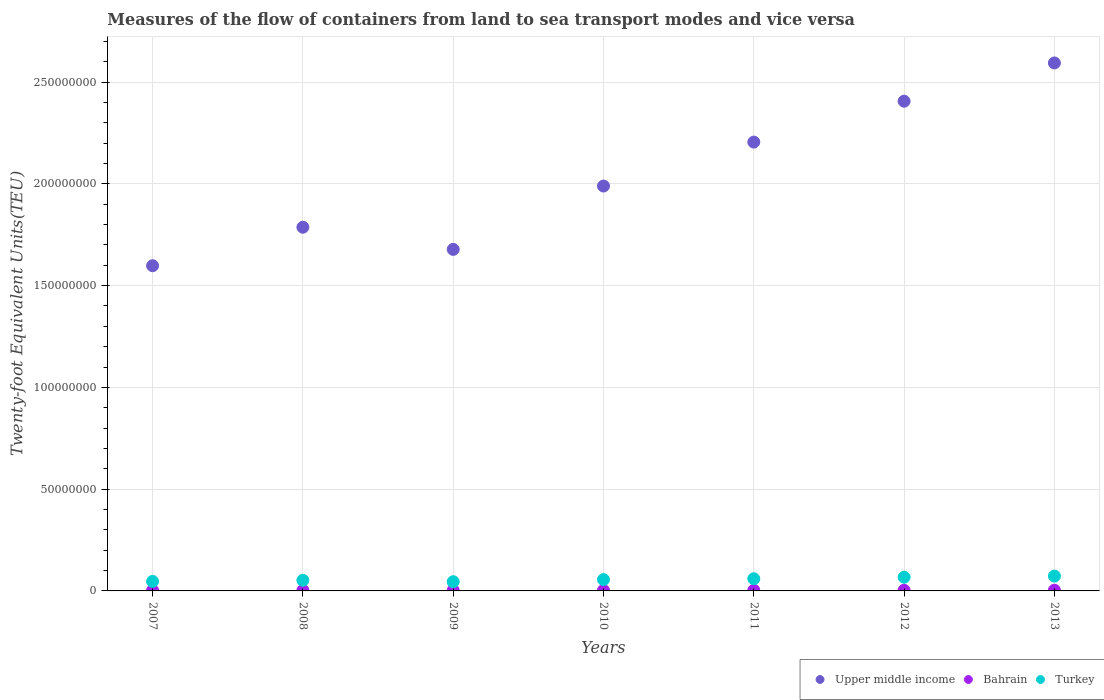What is the container port traffic in Bahrain in 2011?
Provide a short and direct response. 3.06e+05. Across all years, what is the maximum container port traffic in Turkey?
Offer a very short reply. 7.28e+06. Across all years, what is the minimum container port traffic in Upper middle income?
Give a very brief answer. 1.60e+08. In which year was the container port traffic in Upper middle income minimum?
Your response must be concise. 2007. What is the total container port traffic in Bahrain in the graph?
Provide a succinct answer. 2.07e+06. What is the difference between the container port traffic in Upper middle income in 2007 and that in 2013?
Offer a very short reply. -9.96e+07. What is the difference between the container port traffic in Bahrain in 2011 and the container port traffic in Upper middle income in 2007?
Offer a terse response. -1.59e+08. What is the average container port traffic in Upper middle income per year?
Keep it short and to the point. 2.04e+08. In the year 2010, what is the difference between the container port traffic in Turkey and container port traffic in Bahrain?
Your answer should be very brief. 5.28e+06. What is the ratio of the container port traffic in Turkey in 2009 to that in 2013?
Provide a short and direct response. 0.62. Is the difference between the container port traffic in Turkey in 2007 and 2013 greater than the difference between the container port traffic in Bahrain in 2007 and 2013?
Keep it short and to the point. No. What is the difference between the highest and the second highest container port traffic in Turkey?
Give a very brief answer. 5.48e+05. What is the difference between the highest and the lowest container port traffic in Upper middle income?
Your response must be concise. 9.96e+07. In how many years, is the container port traffic in Upper middle income greater than the average container port traffic in Upper middle income taken over all years?
Provide a succinct answer. 3. Is the sum of the container port traffic in Turkey in 2007 and 2012 greater than the maximum container port traffic in Bahrain across all years?
Your answer should be compact. Yes. Is it the case that in every year, the sum of the container port traffic in Turkey and container port traffic in Upper middle income  is greater than the container port traffic in Bahrain?
Your response must be concise. Yes. Is the container port traffic in Bahrain strictly less than the container port traffic in Upper middle income over the years?
Ensure brevity in your answer.  Yes. How many dotlines are there?
Provide a short and direct response. 3. How many years are there in the graph?
Keep it short and to the point. 7. What is the difference between two consecutive major ticks on the Y-axis?
Your response must be concise. 5.00e+07. Are the values on the major ticks of Y-axis written in scientific E-notation?
Ensure brevity in your answer.  No. Does the graph contain any zero values?
Give a very brief answer. No. Does the graph contain grids?
Provide a short and direct response. Yes. Where does the legend appear in the graph?
Your response must be concise. Bottom right. How many legend labels are there?
Provide a short and direct response. 3. What is the title of the graph?
Provide a succinct answer. Measures of the flow of containers from land to sea transport modes and vice versa. Does "Chile" appear as one of the legend labels in the graph?
Keep it short and to the point. No. What is the label or title of the X-axis?
Offer a very short reply. Years. What is the label or title of the Y-axis?
Make the answer very short. Twenty-foot Equivalent Units(TEU). What is the Twenty-foot Equivalent Units(TEU) of Upper middle income in 2007?
Your answer should be compact. 1.60e+08. What is the Twenty-foot Equivalent Units(TEU) of Bahrain in 2007?
Make the answer very short. 2.39e+05. What is the Twenty-foot Equivalent Units(TEU) in Turkey in 2007?
Keep it short and to the point. 4.68e+06. What is the Twenty-foot Equivalent Units(TEU) in Upper middle income in 2008?
Your answer should be very brief. 1.79e+08. What is the Twenty-foot Equivalent Units(TEU) of Bahrain in 2008?
Your answer should be very brief. 2.69e+05. What is the Twenty-foot Equivalent Units(TEU) of Turkey in 2008?
Give a very brief answer. 5.22e+06. What is the Twenty-foot Equivalent Units(TEU) of Upper middle income in 2009?
Your answer should be very brief. 1.68e+08. What is the Twenty-foot Equivalent Units(TEU) of Bahrain in 2009?
Keep it short and to the point. 2.80e+05. What is the Twenty-foot Equivalent Units(TEU) of Turkey in 2009?
Give a very brief answer. 4.52e+06. What is the Twenty-foot Equivalent Units(TEU) of Upper middle income in 2010?
Provide a succinct answer. 1.99e+08. What is the Twenty-foot Equivalent Units(TEU) in Bahrain in 2010?
Make the answer very short. 2.90e+05. What is the Twenty-foot Equivalent Units(TEU) in Turkey in 2010?
Your response must be concise. 5.57e+06. What is the Twenty-foot Equivalent Units(TEU) in Upper middle income in 2011?
Provide a succinct answer. 2.21e+08. What is the Twenty-foot Equivalent Units(TEU) of Bahrain in 2011?
Provide a succinct answer. 3.06e+05. What is the Twenty-foot Equivalent Units(TEU) in Turkey in 2011?
Your answer should be compact. 5.99e+06. What is the Twenty-foot Equivalent Units(TEU) of Upper middle income in 2012?
Give a very brief answer. 2.41e+08. What is the Twenty-foot Equivalent Units(TEU) in Bahrain in 2012?
Provide a succinct answer. 3.29e+05. What is the Twenty-foot Equivalent Units(TEU) of Turkey in 2012?
Provide a succinct answer. 6.74e+06. What is the Twenty-foot Equivalent Units(TEU) in Upper middle income in 2013?
Your answer should be very brief. 2.59e+08. What is the Twenty-foot Equivalent Units(TEU) of Bahrain in 2013?
Provide a succinct answer. 3.55e+05. What is the Twenty-foot Equivalent Units(TEU) in Turkey in 2013?
Make the answer very short. 7.28e+06. Across all years, what is the maximum Twenty-foot Equivalent Units(TEU) of Upper middle income?
Offer a very short reply. 2.59e+08. Across all years, what is the maximum Twenty-foot Equivalent Units(TEU) in Bahrain?
Your answer should be compact. 3.55e+05. Across all years, what is the maximum Twenty-foot Equivalent Units(TEU) in Turkey?
Make the answer very short. 7.28e+06. Across all years, what is the minimum Twenty-foot Equivalent Units(TEU) of Upper middle income?
Give a very brief answer. 1.60e+08. Across all years, what is the minimum Twenty-foot Equivalent Units(TEU) of Bahrain?
Ensure brevity in your answer.  2.39e+05. Across all years, what is the minimum Twenty-foot Equivalent Units(TEU) of Turkey?
Make the answer very short. 4.52e+06. What is the total Twenty-foot Equivalent Units(TEU) of Upper middle income in the graph?
Keep it short and to the point. 1.43e+09. What is the total Twenty-foot Equivalent Units(TEU) of Bahrain in the graph?
Keep it short and to the point. 2.07e+06. What is the total Twenty-foot Equivalent Units(TEU) in Turkey in the graph?
Offer a very short reply. 4.00e+07. What is the difference between the Twenty-foot Equivalent Units(TEU) in Upper middle income in 2007 and that in 2008?
Make the answer very short. -1.89e+07. What is the difference between the Twenty-foot Equivalent Units(TEU) in Bahrain in 2007 and that in 2008?
Make the answer very short. -3.07e+04. What is the difference between the Twenty-foot Equivalent Units(TEU) in Turkey in 2007 and that in 2008?
Offer a terse response. -5.39e+05. What is the difference between the Twenty-foot Equivalent Units(TEU) in Upper middle income in 2007 and that in 2009?
Offer a very short reply. -8.03e+06. What is the difference between the Twenty-foot Equivalent Units(TEU) of Bahrain in 2007 and that in 2009?
Your answer should be compact. -4.12e+04. What is the difference between the Twenty-foot Equivalent Units(TEU) of Turkey in 2007 and that in 2009?
Ensure brevity in your answer.  1.57e+05. What is the difference between the Twenty-foot Equivalent Units(TEU) in Upper middle income in 2007 and that in 2010?
Offer a very short reply. -3.92e+07. What is the difference between the Twenty-foot Equivalent Units(TEU) of Bahrain in 2007 and that in 2010?
Provide a short and direct response. -5.13e+04. What is the difference between the Twenty-foot Equivalent Units(TEU) in Turkey in 2007 and that in 2010?
Ensure brevity in your answer.  -8.95e+05. What is the difference between the Twenty-foot Equivalent Units(TEU) in Upper middle income in 2007 and that in 2011?
Your answer should be compact. -6.07e+07. What is the difference between the Twenty-foot Equivalent Units(TEU) in Bahrain in 2007 and that in 2011?
Give a very brief answer. -6.79e+04. What is the difference between the Twenty-foot Equivalent Units(TEU) in Turkey in 2007 and that in 2011?
Provide a succinct answer. -1.31e+06. What is the difference between the Twenty-foot Equivalent Units(TEU) in Upper middle income in 2007 and that in 2012?
Provide a short and direct response. -8.08e+07. What is the difference between the Twenty-foot Equivalent Units(TEU) in Bahrain in 2007 and that in 2012?
Ensure brevity in your answer.  -9.08e+04. What is the difference between the Twenty-foot Equivalent Units(TEU) of Turkey in 2007 and that in 2012?
Offer a very short reply. -2.06e+06. What is the difference between the Twenty-foot Equivalent Units(TEU) of Upper middle income in 2007 and that in 2013?
Ensure brevity in your answer.  -9.96e+07. What is the difference between the Twenty-foot Equivalent Units(TEU) of Bahrain in 2007 and that in 2013?
Ensure brevity in your answer.  -1.17e+05. What is the difference between the Twenty-foot Equivalent Units(TEU) in Turkey in 2007 and that in 2013?
Offer a very short reply. -2.61e+06. What is the difference between the Twenty-foot Equivalent Units(TEU) of Upper middle income in 2008 and that in 2009?
Your answer should be very brief. 1.09e+07. What is the difference between the Twenty-foot Equivalent Units(TEU) in Bahrain in 2008 and that in 2009?
Provide a succinct answer. -1.05e+04. What is the difference between the Twenty-foot Equivalent Units(TEU) in Turkey in 2008 and that in 2009?
Your response must be concise. 6.97e+05. What is the difference between the Twenty-foot Equivalent Units(TEU) in Upper middle income in 2008 and that in 2010?
Keep it short and to the point. -2.02e+07. What is the difference between the Twenty-foot Equivalent Units(TEU) of Bahrain in 2008 and that in 2010?
Offer a very short reply. -2.06e+04. What is the difference between the Twenty-foot Equivalent Units(TEU) of Turkey in 2008 and that in 2010?
Your response must be concise. -3.56e+05. What is the difference between the Twenty-foot Equivalent Units(TEU) in Upper middle income in 2008 and that in 2011?
Keep it short and to the point. -4.18e+07. What is the difference between the Twenty-foot Equivalent Units(TEU) of Bahrain in 2008 and that in 2011?
Your answer should be very brief. -3.72e+04. What is the difference between the Twenty-foot Equivalent Units(TEU) of Turkey in 2008 and that in 2011?
Provide a short and direct response. -7.72e+05. What is the difference between the Twenty-foot Equivalent Units(TEU) of Upper middle income in 2008 and that in 2012?
Keep it short and to the point. -6.19e+07. What is the difference between the Twenty-foot Equivalent Units(TEU) in Bahrain in 2008 and that in 2012?
Offer a terse response. -6.01e+04. What is the difference between the Twenty-foot Equivalent Units(TEU) of Turkey in 2008 and that in 2012?
Give a very brief answer. -1.52e+06. What is the difference between the Twenty-foot Equivalent Units(TEU) of Upper middle income in 2008 and that in 2013?
Give a very brief answer. -8.07e+07. What is the difference between the Twenty-foot Equivalent Units(TEU) of Bahrain in 2008 and that in 2013?
Provide a short and direct response. -8.62e+04. What is the difference between the Twenty-foot Equivalent Units(TEU) of Turkey in 2008 and that in 2013?
Your answer should be compact. -2.07e+06. What is the difference between the Twenty-foot Equivalent Units(TEU) in Upper middle income in 2009 and that in 2010?
Your answer should be very brief. -3.11e+07. What is the difference between the Twenty-foot Equivalent Units(TEU) of Bahrain in 2009 and that in 2010?
Offer a very short reply. -1.02e+04. What is the difference between the Twenty-foot Equivalent Units(TEU) in Turkey in 2009 and that in 2010?
Make the answer very short. -1.05e+06. What is the difference between the Twenty-foot Equivalent Units(TEU) of Upper middle income in 2009 and that in 2011?
Your answer should be very brief. -5.27e+07. What is the difference between the Twenty-foot Equivalent Units(TEU) of Bahrain in 2009 and that in 2011?
Make the answer very short. -2.67e+04. What is the difference between the Twenty-foot Equivalent Units(TEU) of Turkey in 2009 and that in 2011?
Keep it short and to the point. -1.47e+06. What is the difference between the Twenty-foot Equivalent Units(TEU) in Upper middle income in 2009 and that in 2012?
Provide a short and direct response. -7.28e+07. What is the difference between the Twenty-foot Equivalent Units(TEU) of Bahrain in 2009 and that in 2012?
Provide a succinct answer. -4.97e+04. What is the difference between the Twenty-foot Equivalent Units(TEU) of Turkey in 2009 and that in 2012?
Offer a very short reply. -2.21e+06. What is the difference between the Twenty-foot Equivalent Units(TEU) in Upper middle income in 2009 and that in 2013?
Offer a very short reply. -9.16e+07. What is the difference between the Twenty-foot Equivalent Units(TEU) in Bahrain in 2009 and that in 2013?
Provide a short and direct response. -7.57e+04. What is the difference between the Twenty-foot Equivalent Units(TEU) in Turkey in 2009 and that in 2013?
Give a very brief answer. -2.76e+06. What is the difference between the Twenty-foot Equivalent Units(TEU) of Upper middle income in 2010 and that in 2011?
Your response must be concise. -2.16e+07. What is the difference between the Twenty-foot Equivalent Units(TEU) in Bahrain in 2010 and that in 2011?
Provide a succinct answer. -1.65e+04. What is the difference between the Twenty-foot Equivalent Units(TEU) in Turkey in 2010 and that in 2011?
Keep it short and to the point. -4.16e+05. What is the difference between the Twenty-foot Equivalent Units(TEU) in Upper middle income in 2010 and that in 2012?
Ensure brevity in your answer.  -4.17e+07. What is the difference between the Twenty-foot Equivalent Units(TEU) in Bahrain in 2010 and that in 2012?
Provide a short and direct response. -3.95e+04. What is the difference between the Twenty-foot Equivalent Units(TEU) in Turkey in 2010 and that in 2012?
Offer a very short reply. -1.16e+06. What is the difference between the Twenty-foot Equivalent Units(TEU) of Upper middle income in 2010 and that in 2013?
Give a very brief answer. -6.05e+07. What is the difference between the Twenty-foot Equivalent Units(TEU) in Bahrain in 2010 and that in 2013?
Provide a short and direct response. -6.55e+04. What is the difference between the Twenty-foot Equivalent Units(TEU) of Turkey in 2010 and that in 2013?
Offer a terse response. -1.71e+06. What is the difference between the Twenty-foot Equivalent Units(TEU) in Upper middle income in 2011 and that in 2012?
Offer a terse response. -2.01e+07. What is the difference between the Twenty-foot Equivalent Units(TEU) in Bahrain in 2011 and that in 2012?
Ensure brevity in your answer.  -2.30e+04. What is the difference between the Twenty-foot Equivalent Units(TEU) of Turkey in 2011 and that in 2012?
Provide a succinct answer. -7.46e+05. What is the difference between the Twenty-foot Equivalent Units(TEU) in Upper middle income in 2011 and that in 2013?
Your answer should be compact. -3.89e+07. What is the difference between the Twenty-foot Equivalent Units(TEU) in Bahrain in 2011 and that in 2013?
Your answer should be compact. -4.90e+04. What is the difference between the Twenty-foot Equivalent Units(TEU) of Turkey in 2011 and that in 2013?
Provide a short and direct response. -1.29e+06. What is the difference between the Twenty-foot Equivalent Units(TEU) of Upper middle income in 2012 and that in 2013?
Your answer should be compact. -1.88e+07. What is the difference between the Twenty-foot Equivalent Units(TEU) in Bahrain in 2012 and that in 2013?
Offer a terse response. -2.60e+04. What is the difference between the Twenty-foot Equivalent Units(TEU) of Turkey in 2012 and that in 2013?
Provide a succinct answer. -5.48e+05. What is the difference between the Twenty-foot Equivalent Units(TEU) in Upper middle income in 2007 and the Twenty-foot Equivalent Units(TEU) in Bahrain in 2008?
Give a very brief answer. 1.60e+08. What is the difference between the Twenty-foot Equivalent Units(TEU) of Upper middle income in 2007 and the Twenty-foot Equivalent Units(TEU) of Turkey in 2008?
Ensure brevity in your answer.  1.55e+08. What is the difference between the Twenty-foot Equivalent Units(TEU) of Bahrain in 2007 and the Twenty-foot Equivalent Units(TEU) of Turkey in 2008?
Provide a short and direct response. -4.98e+06. What is the difference between the Twenty-foot Equivalent Units(TEU) of Upper middle income in 2007 and the Twenty-foot Equivalent Units(TEU) of Bahrain in 2009?
Your answer should be very brief. 1.60e+08. What is the difference between the Twenty-foot Equivalent Units(TEU) of Upper middle income in 2007 and the Twenty-foot Equivalent Units(TEU) of Turkey in 2009?
Ensure brevity in your answer.  1.55e+08. What is the difference between the Twenty-foot Equivalent Units(TEU) in Bahrain in 2007 and the Twenty-foot Equivalent Units(TEU) in Turkey in 2009?
Keep it short and to the point. -4.28e+06. What is the difference between the Twenty-foot Equivalent Units(TEU) in Upper middle income in 2007 and the Twenty-foot Equivalent Units(TEU) in Bahrain in 2010?
Provide a succinct answer. 1.59e+08. What is the difference between the Twenty-foot Equivalent Units(TEU) of Upper middle income in 2007 and the Twenty-foot Equivalent Units(TEU) of Turkey in 2010?
Provide a succinct answer. 1.54e+08. What is the difference between the Twenty-foot Equivalent Units(TEU) in Bahrain in 2007 and the Twenty-foot Equivalent Units(TEU) in Turkey in 2010?
Provide a succinct answer. -5.34e+06. What is the difference between the Twenty-foot Equivalent Units(TEU) of Upper middle income in 2007 and the Twenty-foot Equivalent Units(TEU) of Bahrain in 2011?
Your answer should be very brief. 1.59e+08. What is the difference between the Twenty-foot Equivalent Units(TEU) in Upper middle income in 2007 and the Twenty-foot Equivalent Units(TEU) in Turkey in 2011?
Provide a succinct answer. 1.54e+08. What is the difference between the Twenty-foot Equivalent Units(TEU) in Bahrain in 2007 and the Twenty-foot Equivalent Units(TEU) in Turkey in 2011?
Your response must be concise. -5.75e+06. What is the difference between the Twenty-foot Equivalent Units(TEU) in Upper middle income in 2007 and the Twenty-foot Equivalent Units(TEU) in Bahrain in 2012?
Provide a short and direct response. 1.59e+08. What is the difference between the Twenty-foot Equivalent Units(TEU) in Upper middle income in 2007 and the Twenty-foot Equivalent Units(TEU) in Turkey in 2012?
Offer a very short reply. 1.53e+08. What is the difference between the Twenty-foot Equivalent Units(TEU) in Bahrain in 2007 and the Twenty-foot Equivalent Units(TEU) in Turkey in 2012?
Give a very brief answer. -6.50e+06. What is the difference between the Twenty-foot Equivalent Units(TEU) in Upper middle income in 2007 and the Twenty-foot Equivalent Units(TEU) in Bahrain in 2013?
Offer a terse response. 1.59e+08. What is the difference between the Twenty-foot Equivalent Units(TEU) of Upper middle income in 2007 and the Twenty-foot Equivalent Units(TEU) of Turkey in 2013?
Keep it short and to the point. 1.53e+08. What is the difference between the Twenty-foot Equivalent Units(TEU) of Bahrain in 2007 and the Twenty-foot Equivalent Units(TEU) of Turkey in 2013?
Ensure brevity in your answer.  -7.05e+06. What is the difference between the Twenty-foot Equivalent Units(TEU) of Upper middle income in 2008 and the Twenty-foot Equivalent Units(TEU) of Bahrain in 2009?
Offer a very short reply. 1.78e+08. What is the difference between the Twenty-foot Equivalent Units(TEU) in Upper middle income in 2008 and the Twenty-foot Equivalent Units(TEU) in Turkey in 2009?
Keep it short and to the point. 1.74e+08. What is the difference between the Twenty-foot Equivalent Units(TEU) in Bahrain in 2008 and the Twenty-foot Equivalent Units(TEU) in Turkey in 2009?
Provide a short and direct response. -4.25e+06. What is the difference between the Twenty-foot Equivalent Units(TEU) of Upper middle income in 2008 and the Twenty-foot Equivalent Units(TEU) of Bahrain in 2010?
Give a very brief answer. 1.78e+08. What is the difference between the Twenty-foot Equivalent Units(TEU) in Upper middle income in 2008 and the Twenty-foot Equivalent Units(TEU) in Turkey in 2010?
Make the answer very short. 1.73e+08. What is the difference between the Twenty-foot Equivalent Units(TEU) of Bahrain in 2008 and the Twenty-foot Equivalent Units(TEU) of Turkey in 2010?
Your answer should be very brief. -5.30e+06. What is the difference between the Twenty-foot Equivalent Units(TEU) in Upper middle income in 2008 and the Twenty-foot Equivalent Units(TEU) in Bahrain in 2011?
Offer a terse response. 1.78e+08. What is the difference between the Twenty-foot Equivalent Units(TEU) of Upper middle income in 2008 and the Twenty-foot Equivalent Units(TEU) of Turkey in 2011?
Make the answer very short. 1.73e+08. What is the difference between the Twenty-foot Equivalent Units(TEU) of Bahrain in 2008 and the Twenty-foot Equivalent Units(TEU) of Turkey in 2011?
Your answer should be very brief. -5.72e+06. What is the difference between the Twenty-foot Equivalent Units(TEU) in Upper middle income in 2008 and the Twenty-foot Equivalent Units(TEU) in Bahrain in 2012?
Provide a succinct answer. 1.78e+08. What is the difference between the Twenty-foot Equivalent Units(TEU) of Upper middle income in 2008 and the Twenty-foot Equivalent Units(TEU) of Turkey in 2012?
Your answer should be compact. 1.72e+08. What is the difference between the Twenty-foot Equivalent Units(TEU) of Bahrain in 2008 and the Twenty-foot Equivalent Units(TEU) of Turkey in 2012?
Your answer should be compact. -6.47e+06. What is the difference between the Twenty-foot Equivalent Units(TEU) of Upper middle income in 2008 and the Twenty-foot Equivalent Units(TEU) of Bahrain in 2013?
Give a very brief answer. 1.78e+08. What is the difference between the Twenty-foot Equivalent Units(TEU) of Upper middle income in 2008 and the Twenty-foot Equivalent Units(TEU) of Turkey in 2013?
Offer a terse response. 1.71e+08. What is the difference between the Twenty-foot Equivalent Units(TEU) of Bahrain in 2008 and the Twenty-foot Equivalent Units(TEU) of Turkey in 2013?
Your answer should be compact. -7.01e+06. What is the difference between the Twenty-foot Equivalent Units(TEU) in Upper middle income in 2009 and the Twenty-foot Equivalent Units(TEU) in Bahrain in 2010?
Your response must be concise. 1.68e+08. What is the difference between the Twenty-foot Equivalent Units(TEU) in Upper middle income in 2009 and the Twenty-foot Equivalent Units(TEU) in Turkey in 2010?
Give a very brief answer. 1.62e+08. What is the difference between the Twenty-foot Equivalent Units(TEU) of Bahrain in 2009 and the Twenty-foot Equivalent Units(TEU) of Turkey in 2010?
Provide a succinct answer. -5.29e+06. What is the difference between the Twenty-foot Equivalent Units(TEU) in Upper middle income in 2009 and the Twenty-foot Equivalent Units(TEU) in Bahrain in 2011?
Your response must be concise. 1.68e+08. What is the difference between the Twenty-foot Equivalent Units(TEU) in Upper middle income in 2009 and the Twenty-foot Equivalent Units(TEU) in Turkey in 2011?
Your response must be concise. 1.62e+08. What is the difference between the Twenty-foot Equivalent Units(TEU) of Bahrain in 2009 and the Twenty-foot Equivalent Units(TEU) of Turkey in 2011?
Offer a terse response. -5.71e+06. What is the difference between the Twenty-foot Equivalent Units(TEU) of Upper middle income in 2009 and the Twenty-foot Equivalent Units(TEU) of Bahrain in 2012?
Your response must be concise. 1.67e+08. What is the difference between the Twenty-foot Equivalent Units(TEU) of Upper middle income in 2009 and the Twenty-foot Equivalent Units(TEU) of Turkey in 2012?
Your response must be concise. 1.61e+08. What is the difference between the Twenty-foot Equivalent Units(TEU) in Bahrain in 2009 and the Twenty-foot Equivalent Units(TEU) in Turkey in 2012?
Ensure brevity in your answer.  -6.46e+06. What is the difference between the Twenty-foot Equivalent Units(TEU) in Upper middle income in 2009 and the Twenty-foot Equivalent Units(TEU) in Bahrain in 2013?
Provide a short and direct response. 1.67e+08. What is the difference between the Twenty-foot Equivalent Units(TEU) in Upper middle income in 2009 and the Twenty-foot Equivalent Units(TEU) in Turkey in 2013?
Keep it short and to the point. 1.61e+08. What is the difference between the Twenty-foot Equivalent Units(TEU) of Bahrain in 2009 and the Twenty-foot Equivalent Units(TEU) of Turkey in 2013?
Make the answer very short. -7.00e+06. What is the difference between the Twenty-foot Equivalent Units(TEU) in Upper middle income in 2010 and the Twenty-foot Equivalent Units(TEU) in Bahrain in 2011?
Make the answer very short. 1.99e+08. What is the difference between the Twenty-foot Equivalent Units(TEU) of Upper middle income in 2010 and the Twenty-foot Equivalent Units(TEU) of Turkey in 2011?
Provide a succinct answer. 1.93e+08. What is the difference between the Twenty-foot Equivalent Units(TEU) in Bahrain in 2010 and the Twenty-foot Equivalent Units(TEU) in Turkey in 2011?
Make the answer very short. -5.70e+06. What is the difference between the Twenty-foot Equivalent Units(TEU) in Upper middle income in 2010 and the Twenty-foot Equivalent Units(TEU) in Bahrain in 2012?
Your answer should be very brief. 1.99e+08. What is the difference between the Twenty-foot Equivalent Units(TEU) in Upper middle income in 2010 and the Twenty-foot Equivalent Units(TEU) in Turkey in 2012?
Provide a succinct answer. 1.92e+08. What is the difference between the Twenty-foot Equivalent Units(TEU) of Bahrain in 2010 and the Twenty-foot Equivalent Units(TEU) of Turkey in 2012?
Your answer should be very brief. -6.45e+06. What is the difference between the Twenty-foot Equivalent Units(TEU) of Upper middle income in 2010 and the Twenty-foot Equivalent Units(TEU) of Bahrain in 2013?
Provide a succinct answer. 1.99e+08. What is the difference between the Twenty-foot Equivalent Units(TEU) of Upper middle income in 2010 and the Twenty-foot Equivalent Units(TEU) of Turkey in 2013?
Provide a short and direct response. 1.92e+08. What is the difference between the Twenty-foot Equivalent Units(TEU) in Bahrain in 2010 and the Twenty-foot Equivalent Units(TEU) in Turkey in 2013?
Provide a succinct answer. -6.99e+06. What is the difference between the Twenty-foot Equivalent Units(TEU) in Upper middle income in 2011 and the Twenty-foot Equivalent Units(TEU) in Bahrain in 2012?
Ensure brevity in your answer.  2.20e+08. What is the difference between the Twenty-foot Equivalent Units(TEU) in Upper middle income in 2011 and the Twenty-foot Equivalent Units(TEU) in Turkey in 2012?
Keep it short and to the point. 2.14e+08. What is the difference between the Twenty-foot Equivalent Units(TEU) in Bahrain in 2011 and the Twenty-foot Equivalent Units(TEU) in Turkey in 2012?
Offer a very short reply. -6.43e+06. What is the difference between the Twenty-foot Equivalent Units(TEU) in Upper middle income in 2011 and the Twenty-foot Equivalent Units(TEU) in Bahrain in 2013?
Offer a very short reply. 2.20e+08. What is the difference between the Twenty-foot Equivalent Units(TEU) of Upper middle income in 2011 and the Twenty-foot Equivalent Units(TEU) of Turkey in 2013?
Your response must be concise. 2.13e+08. What is the difference between the Twenty-foot Equivalent Units(TEU) of Bahrain in 2011 and the Twenty-foot Equivalent Units(TEU) of Turkey in 2013?
Offer a very short reply. -6.98e+06. What is the difference between the Twenty-foot Equivalent Units(TEU) in Upper middle income in 2012 and the Twenty-foot Equivalent Units(TEU) in Bahrain in 2013?
Your answer should be very brief. 2.40e+08. What is the difference between the Twenty-foot Equivalent Units(TEU) in Upper middle income in 2012 and the Twenty-foot Equivalent Units(TEU) in Turkey in 2013?
Offer a very short reply. 2.33e+08. What is the difference between the Twenty-foot Equivalent Units(TEU) of Bahrain in 2012 and the Twenty-foot Equivalent Units(TEU) of Turkey in 2013?
Your answer should be compact. -6.95e+06. What is the average Twenty-foot Equivalent Units(TEU) in Upper middle income per year?
Your answer should be very brief. 2.04e+08. What is the average Twenty-foot Equivalent Units(TEU) of Bahrain per year?
Ensure brevity in your answer.  2.96e+05. What is the average Twenty-foot Equivalent Units(TEU) in Turkey per year?
Ensure brevity in your answer.  5.71e+06. In the year 2007, what is the difference between the Twenty-foot Equivalent Units(TEU) in Upper middle income and Twenty-foot Equivalent Units(TEU) in Bahrain?
Your response must be concise. 1.60e+08. In the year 2007, what is the difference between the Twenty-foot Equivalent Units(TEU) in Upper middle income and Twenty-foot Equivalent Units(TEU) in Turkey?
Your answer should be compact. 1.55e+08. In the year 2007, what is the difference between the Twenty-foot Equivalent Units(TEU) of Bahrain and Twenty-foot Equivalent Units(TEU) of Turkey?
Give a very brief answer. -4.44e+06. In the year 2008, what is the difference between the Twenty-foot Equivalent Units(TEU) in Upper middle income and Twenty-foot Equivalent Units(TEU) in Bahrain?
Keep it short and to the point. 1.78e+08. In the year 2008, what is the difference between the Twenty-foot Equivalent Units(TEU) in Upper middle income and Twenty-foot Equivalent Units(TEU) in Turkey?
Offer a very short reply. 1.73e+08. In the year 2008, what is the difference between the Twenty-foot Equivalent Units(TEU) in Bahrain and Twenty-foot Equivalent Units(TEU) in Turkey?
Your response must be concise. -4.95e+06. In the year 2009, what is the difference between the Twenty-foot Equivalent Units(TEU) in Upper middle income and Twenty-foot Equivalent Units(TEU) in Bahrain?
Provide a succinct answer. 1.68e+08. In the year 2009, what is the difference between the Twenty-foot Equivalent Units(TEU) in Upper middle income and Twenty-foot Equivalent Units(TEU) in Turkey?
Your answer should be compact. 1.63e+08. In the year 2009, what is the difference between the Twenty-foot Equivalent Units(TEU) in Bahrain and Twenty-foot Equivalent Units(TEU) in Turkey?
Keep it short and to the point. -4.24e+06. In the year 2010, what is the difference between the Twenty-foot Equivalent Units(TEU) in Upper middle income and Twenty-foot Equivalent Units(TEU) in Bahrain?
Offer a very short reply. 1.99e+08. In the year 2010, what is the difference between the Twenty-foot Equivalent Units(TEU) in Upper middle income and Twenty-foot Equivalent Units(TEU) in Turkey?
Offer a very short reply. 1.93e+08. In the year 2010, what is the difference between the Twenty-foot Equivalent Units(TEU) of Bahrain and Twenty-foot Equivalent Units(TEU) of Turkey?
Offer a terse response. -5.28e+06. In the year 2011, what is the difference between the Twenty-foot Equivalent Units(TEU) in Upper middle income and Twenty-foot Equivalent Units(TEU) in Bahrain?
Provide a succinct answer. 2.20e+08. In the year 2011, what is the difference between the Twenty-foot Equivalent Units(TEU) in Upper middle income and Twenty-foot Equivalent Units(TEU) in Turkey?
Offer a very short reply. 2.15e+08. In the year 2011, what is the difference between the Twenty-foot Equivalent Units(TEU) of Bahrain and Twenty-foot Equivalent Units(TEU) of Turkey?
Your answer should be very brief. -5.68e+06. In the year 2012, what is the difference between the Twenty-foot Equivalent Units(TEU) of Upper middle income and Twenty-foot Equivalent Units(TEU) of Bahrain?
Keep it short and to the point. 2.40e+08. In the year 2012, what is the difference between the Twenty-foot Equivalent Units(TEU) of Upper middle income and Twenty-foot Equivalent Units(TEU) of Turkey?
Make the answer very short. 2.34e+08. In the year 2012, what is the difference between the Twenty-foot Equivalent Units(TEU) of Bahrain and Twenty-foot Equivalent Units(TEU) of Turkey?
Provide a succinct answer. -6.41e+06. In the year 2013, what is the difference between the Twenty-foot Equivalent Units(TEU) in Upper middle income and Twenty-foot Equivalent Units(TEU) in Bahrain?
Provide a succinct answer. 2.59e+08. In the year 2013, what is the difference between the Twenty-foot Equivalent Units(TEU) of Upper middle income and Twenty-foot Equivalent Units(TEU) of Turkey?
Your answer should be very brief. 2.52e+08. In the year 2013, what is the difference between the Twenty-foot Equivalent Units(TEU) in Bahrain and Twenty-foot Equivalent Units(TEU) in Turkey?
Ensure brevity in your answer.  -6.93e+06. What is the ratio of the Twenty-foot Equivalent Units(TEU) of Upper middle income in 2007 to that in 2008?
Your answer should be very brief. 0.89. What is the ratio of the Twenty-foot Equivalent Units(TEU) in Bahrain in 2007 to that in 2008?
Your answer should be very brief. 0.89. What is the ratio of the Twenty-foot Equivalent Units(TEU) in Turkey in 2007 to that in 2008?
Give a very brief answer. 0.9. What is the ratio of the Twenty-foot Equivalent Units(TEU) of Upper middle income in 2007 to that in 2009?
Your answer should be compact. 0.95. What is the ratio of the Twenty-foot Equivalent Units(TEU) in Bahrain in 2007 to that in 2009?
Your answer should be very brief. 0.85. What is the ratio of the Twenty-foot Equivalent Units(TEU) in Turkey in 2007 to that in 2009?
Your answer should be very brief. 1.03. What is the ratio of the Twenty-foot Equivalent Units(TEU) of Upper middle income in 2007 to that in 2010?
Your answer should be compact. 0.8. What is the ratio of the Twenty-foot Equivalent Units(TEU) in Bahrain in 2007 to that in 2010?
Your response must be concise. 0.82. What is the ratio of the Twenty-foot Equivalent Units(TEU) in Turkey in 2007 to that in 2010?
Your answer should be very brief. 0.84. What is the ratio of the Twenty-foot Equivalent Units(TEU) in Upper middle income in 2007 to that in 2011?
Your response must be concise. 0.72. What is the ratio of the Twenty-foot Equivalent Units(TEU) in Bahrain in 2007 to that in 2011?
Your answer should be very brief. 0.78. What is the ratio of the Twenty-foot Equivalent Units(TEU) of Turkey in 2007 to that in 2011?
Make the answer very short. 0.78. What is the ratio of the Twenty-foot Equivalent Units(TEU) in Upper middle income in 2007 to that in 2012?
Your answer should be compact. 0.66. What is the ratio of the Twenty-foot Equivalent Units(TEU) of Bahrain in 2007 to that in 2012?
Your answer should be very brief. 0.72. What is the ratio of the Twenty-foot Equivalent Units(TEU) of Turkey in 2007 to that in 2012?
Offer a terse response. 0.69. What is the ratio of the Twenty-foot Equivalent Units(TEU) of Upper middle income in 2007 to that in 2013?
Your response must be concise. 0.62. What is the ratio of the Twenty-foot Equivalent Units(TEU) of Bahrain in 2007 to that in 2013?
Keep it short and to the point. 0.67. What is the ratio of the Twenty-foot Equivalent Units(TEU) in Turkey in 2007 to that in 2013?
Your answer should be very brief. 0.64. What is the ratio of the Twenty-foot Equivalent Units(TEU) in Upper middle income in 2008 to that in 2009?
Your response must be concise. 1.06. What is the ratio of the Twenty-foot Equivalent Units(TEU) in Bahrain in 2008 to that in 2009?
Your answer should be very brief. 0.96. What is the ratio of the Twenty-foot Equivalent Units(TEU) of Turkey in 2008 to that in 2009?
Offer a very short reply. 1.15. What is the ratio of the Twenty-foot Equivalent Units(TEU) in Upper middle income in 2008 to that in 2010?
Provide a short and direct response. 0.9. What is the ratio of the Twenty-foot Equivalent Units(TEU) of Bahrain in 2008 to that in 2010?
Ensure brevity in your answer.  0.93. What is the ratio of the Twenty-foot Equivalent Units(TEU) in Turkey in 2008 to that in 2010?
Your answer should be very brief. 0.94. What is the ratio of the Twenty-foot Equivalent Units(TEU) in Upper middle income in 2008 to that in 2011?
Your response must be concise. 0.81. What is the ratio of the Twenty-foot Equivalent Units(TEU) of Bahrain in 2008 to that in 2011?
Make the answer very short. 0.88. What is the ratio of the Twenty-foot Equivalent Units(TEU) of Turkey in 2008 to that in 2011?
Your answer should be very brief. 0.87. What is the ratio of the Twenty-foot Equivalent Units(TEU) in Upper middle income in 2008 to that in 2012?
Your answer should be very brief. 0.74. What is the ratio of the Twenty-foot Equivalent Units(TEU) of Bahrain in 2008 to that in 2012?
Provide a succinct answer. 0.82. What is the ratio of the Twenty-foot Equivalent Units(TEU) of Turkey in 2008 to that in 2012?
Your answer should be compact. 0.77. What is the ratio of the Twenty-foot Equivalent Units(TEU) of Upper middle income in 2008 to that in 2013?
Ensure brevity in your answer.  0.69. What is the ratio of the Twenty-foot Equivalent Units(TEU) in Bahrain in 2008 to that in 2013?
Offer a very short reply. 0.76. What is the ratio of the Twenty-foot Equivalent Units(TEU) of Turkey in 2008 to that in 2013?
Keep it short and to the point. 0.72. What is the ratio of the Twenty-foot Equivalent Units(TEU) of Upper middle income in 2009 to that in 2010?
Your response must be concise. 0.84. What is the ratio of the Twenty-foot Equivalent Units(TEU) of Turkey in 2009 to that in 2010?
Your response must be concise. 0.81. What is the ratio of the Twenty-foot Equivalent Units(TEU) in Upper middle income in 2009 to that in 2011?
Provide a succinct answer. 0.76. What is the ratio of the Twenty-foot Equivalent Units(TEU) of Bahrain in 2009 to that in 2011?
Keep it short and to the point. 0.91. What is the ratio of the Twenty-foot Equivalent Units(TEU) in Turkey in 2009 to that in 2011?
Keep it short and to the point. 0.75. What is the ratio of the Twenty-foot Equivalent Units(TEU) of Upper middle income in 2009 to that in 2012?
Offer a terse response. 0.7. What is the ratio of the Twenty-foot Equivalent Units(TEU) in Bahrain in 2009 to that in 2012?
Make the answer very short. 0.85. What is the ratio of the Twenty-foot Equivalent Units(TEU) of Turkey in 2009 to that in 2012?
Ensure brevity in your answer.  0.67. What is the ratio of the Twenty-foot Equivalent Units(TEU) of Upper middle income in 2009 to that in 2013?
Provide a short and direct response. 0.65. What is the ratio of the Twenty-foot Equivalent Units(TEU) of Bahrain in 2009 to that in 2013?
Provide a succinct answer. 0.79. What is the ratio of the Twenty-foot Equivalent Units(TEU) in Turkey in 2009 to that in 2013?
Make the answer very short. 0.62. What is the ratio of the Twenty-foot Equivalent Units(TEU) in Upper middle income in 2010 to that in 2011?
Give a very brief answer. 0.9. What is the ratio of the Twenty-foot Equivalent Units(TEU) in Bahrain in 2010 to that in 2011?
Provide a succinct answer. 0.95. What is the ratio of the Twenty-foot Equivalent Units(TEU) in Turkey in 2010 to that in 2011?
Offer a terse response. 0.93. What is the ratio of the Twenty-foot Equivalent Units(TEU) of Upper middle income in 2010 to that in 2012?
Make the answer very short. 0.83. What is the ratio of the Twenty-foot Equivalent Units(TEU) in Bahrain in 2010 to that in 2012?
Provide a succinct answer. 0.88. What is the ratio of the Twenty-foot Equivalent Units(TEU) in Turkey in 2010 to that in 2012?
Provide a short and direct response. 0.83. What is the ratio of the Twenty-foot Equivalent Units(TEU) in Upper middle income in 2010 to that in 2013?
Keep it short and to the point. 0.77. What is the ratio of the Twenty-foot Equivalent Units(TEU) in Bahrain in 2010 to that in 2013?
Offer a terse response. 0.82. What is the ratio of the Twenty-foot Equivalent Units(TEU) of Turkey in 2010 to that in 2013?
Your answer should be very brief. 0.77. What is the ratio of the Twenty-foot Equivalent Units(TEU) in Upper middle income in 2011 to that in 2012?
Provide a succinct answer. 0.92. What is the ratio of the Twenty-foot Equivalent Units(TEU) of Bahrain in 2011 to that in 2012?
Keep it short and to the point. 0.93. What is the ratio of the Twenty-foot Equivalent Units(TEU) of Turkey in 2011 to that in 2012?
Keep it short and to the point. 0.89. What is the ratio of the Twenty-foot Equivalent Units(TEU) of Upper middle income in 2011 to that in 2013?
Provide a succinct answer. 0.85. What is the ratio of the Twenty-foot Equivalent Units(TEU) of Bahrain in 2011 to that in 2013?
Your answer should be very brief. 0.86. What is the ratio of the Twenty-foot Equivalent Units(TEU) in Turkey in 2011 to that in 2013?
Your answer should be compact. 0.82. What is the ratio of the Twenty-foot Equivalent Units(TEU) of Upper middle income in 2012 to that in 2013?
Ensure brevity in your answer.  0.93. What is the ratio of the Twenty-foot Equivalent Units(TEU) of Bahrain in 2012 to that in 2013?
Your answer should be very brief. 0.93. What is the ratio of the Twenty-foot Equivalent Units(TEU) in Turkey in 2012 to that in 2013?
Provide a short and direct response. 0.92. What is the difference between the highest and the second highest Twenty-foot Equivalent Units(TEU) of Upper middle income?
Make the answer very short. 1.88e+07. What is the difference between the highest and the second highest Twenty-foot Equivalent Units(TEU) in Bahrain?
Provide a succinct answer. 2.60e+04. What is the difference between the highest and the second highest Twenty-foot Equivalent Units(TEU) of Turkey?
Your response must be concise. 5.48e+05. What is the difference between the highest and the lowest Twenty-foot Equivalent Units(TEU) in Upper middle income?
Make the answer very short. 9.96e+07. What is the difference between the highest and the lowest Twenty-foot Equivalent Units(TEU) in Bahrain?
Ensure brevity in your answer.  1.17e+05. What is the difference between the highest and the lowest Twenty-foot Equivalent Units(TEU) in Turkey?
Provide a short and direct response. 2.76e+06. 